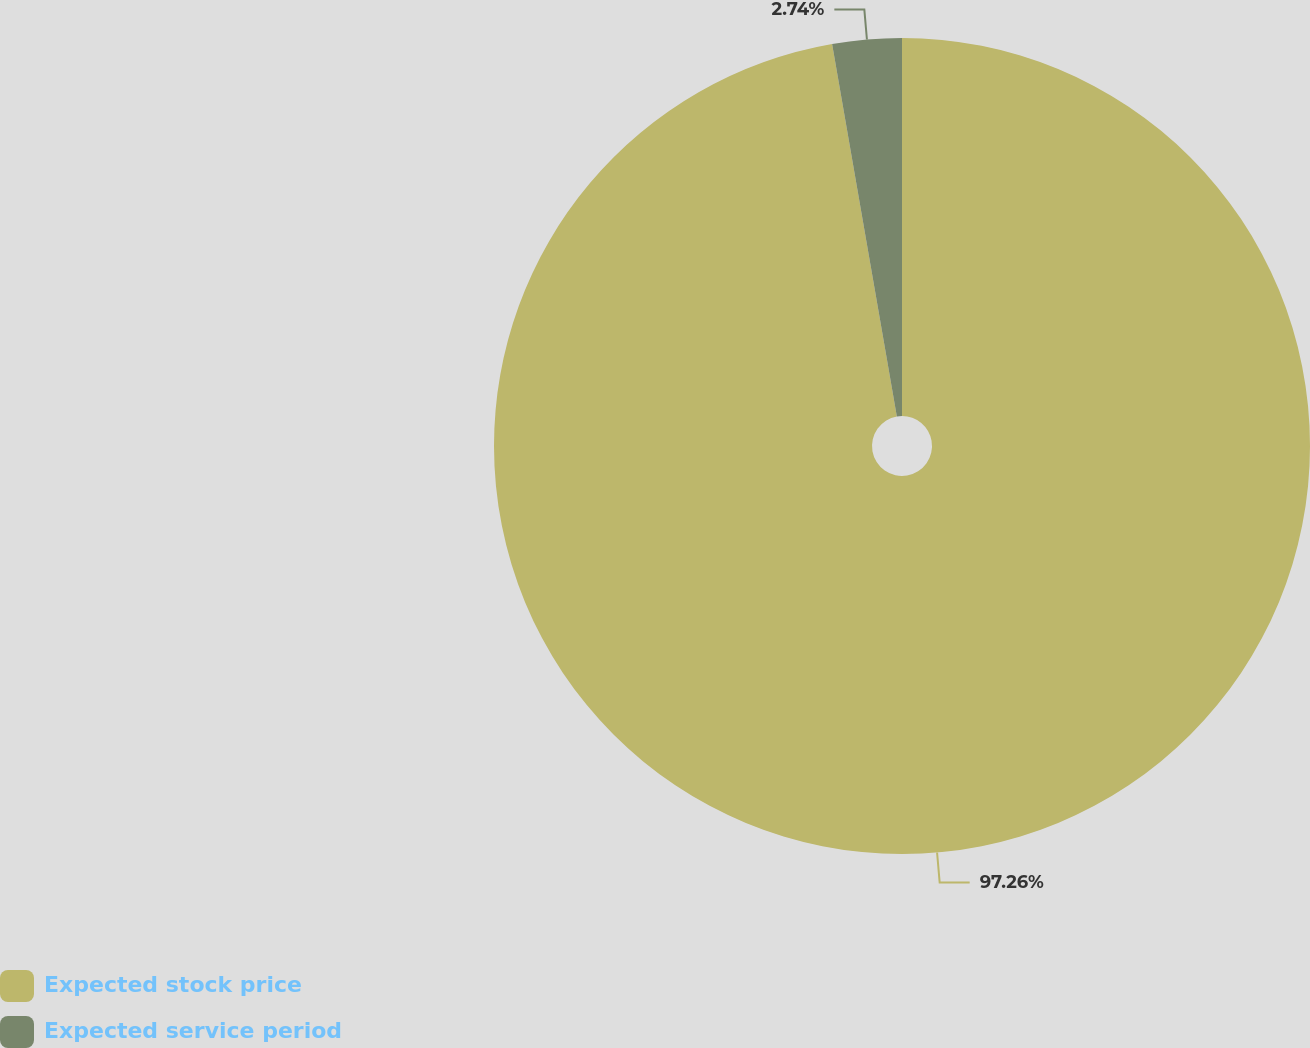Convert chart. <chart><loc_0><loc_0><loc_500><loc_500><pie_chart><fcel>Expected stock price<fcel>Expected service period<nl><fcel>97.26%<fcel>2.74%<nl></chart> 